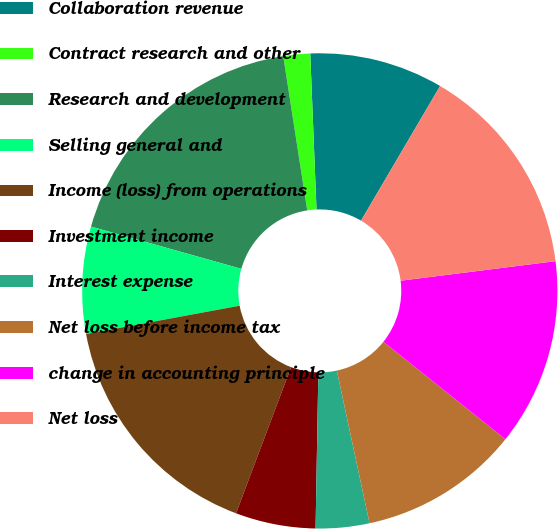Convert chart to OTSL. <chart><loc_0><loc_0><loc_500><loc_500><pie_chart><fcel>Collaboration revenue<fcel>Contract research and other<fcel>Research and development<fcel>Selling general and<fcel>Income (loss) from operations<fcel>Investment income<fcel>Interest expense<fcel>Net loss before income tax<fcel>change in accounting principle<fcel>Net loss<nl><fcel>9.09%<fcel>1.82%<fcel>18.18%<fcel>7.27%<fcel>16.36%<fcel>5.45%<fcel>3.64%<fcel>10.91%<fcel>12.73%<fcel>14.55%<nl></chart> 